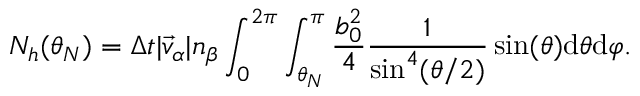<formula> <loc_0><loc_0><loc_500><loc_500>N _ { h } ( \theta _ { N } ) = \Delta t | \vec { v } _ { \alpha } | n _ { \beta } \int _ { 0 } ^ { 2 \pi } \int _ { \theta _ { N } } ^ { \pi } \frac { b _ { 0 } ^ { 2 } } { 4 } \frac { 1 } { \sin ^ { 4 } ( \theta / 2 ) } \sin ( \theta ) d \theta d \varphi .</formula> 